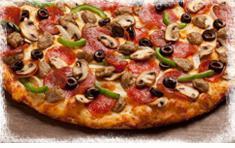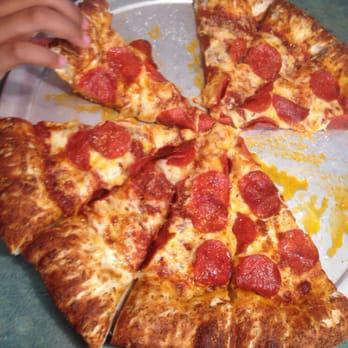The first image is the image on the left, the second image is the image on the right. Assess this claim about the two images: "There is a pizza with exactly one missing slice.". Correct or not? Answer yes or no. No. The first image is the image on the left, the second image is the image on the right. Analyze the images presented: Is the assertion "There's a whole head of garlic and at least one tomato next to the pizza in one of the pictures." valid? Answer yes or no. No. 